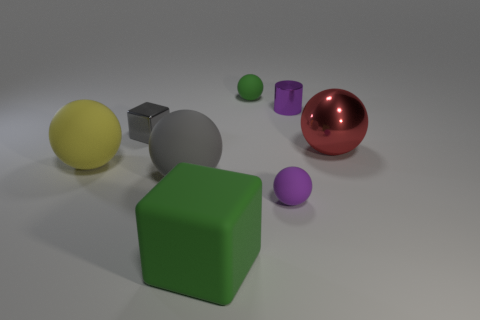Subtract 2 spheres. How many spheres are left? 3 Subtract all green spheres. How many spheres are left? 4 Subtract all green balls. How many balls are left? 4 Subtract all cyan balls. Subtract all green cylinders. How many balls are left? 5 Add 1 small gray metal cylinders. How many objects exist? 9 Subtract all cubes. How many objects are left? 6 Add 1 tiny matte things. How many tiny matte things are left? 3 Add 5 small yellow metallic things. How many small yellow metallic things exist? 5 Subtract 0 red cubes. How many objects are left? 8 Subtract all gray matte spheres. Subtract all purple objects. How many objects are left? 5 